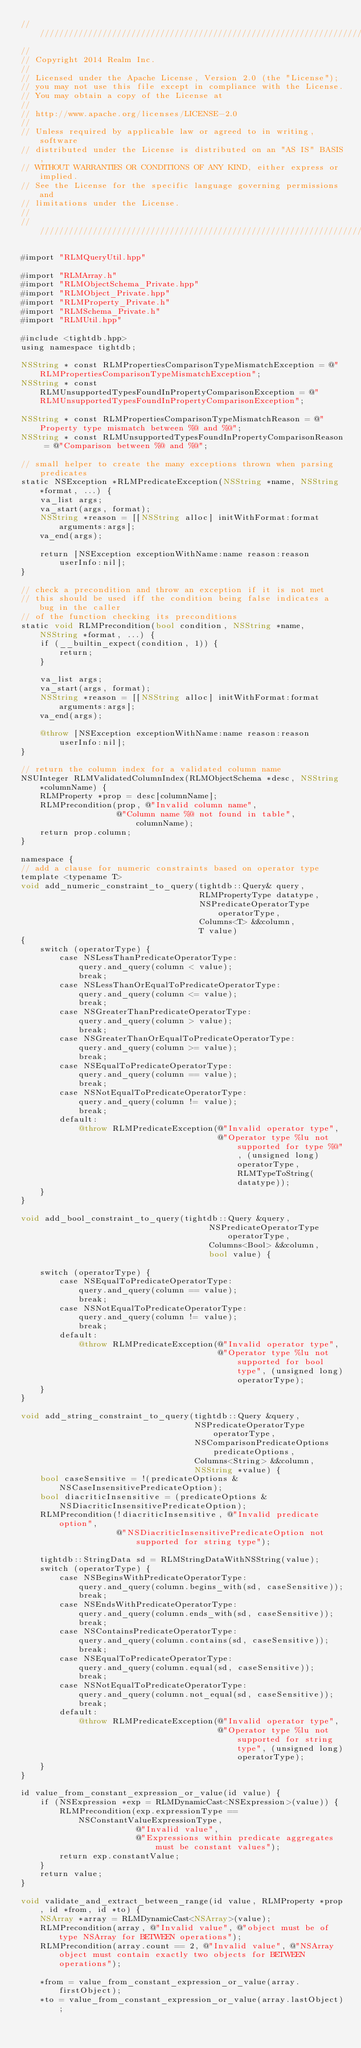Convert code to text. <code><loc_0><loc_0><loc_500><loc_500><_ObjectiveC_>////////////////////////////////////////////////////////////////////////////
//
// Copyright 2014 Realm Inc.
//
// Licensed under the Apache License, Version 2.0 (the "License");
// you may not use this file except in compliance with the License.
// You may obtain a copy of the License at
//
// http://www.apache.org/licenses/LICENSE-2.0
//
// Unless required by applicable law or agreed to in writing, software
// distributed under the License is distributed on an "AS IS" BASIS,
// WITHOUT WARRANTIES OR CONDITIONS OF ANY KIND, either express or implied.
// See the License for the specific language governing permissions and
// limitations under the License.
//
////////////////////////////////////////////////////////////////////////////

#import "RLMQueryUtil.hpp"

#import "RLMArray.h"
#import "RLMObjectSchema_Private.hpp"
#import "RLMObject_Private.hpp"
#import "RLMProperty_Private.h"
#import "RLMSchema_Private.h"
#import "RLMUtil.hpp"

#include <tightdb.hpp>
using namespace tightdb;

NSString * const RLMPropertiesComparisonTypeMismatchException = @"RLMPropertiesComparisonTypeMismatchException";
NSString * const RLMUnsupportedTypesFoundInPropertyComparisonException = @"RLMUnsupportedTypesFoundInPropertyComparisonException";

NSString * const RLMPropertiesComparisonTypeMismatchReason = @"Property type mismatch between %@ and %@";
NSString * const RLMUnsupportedTypesFoundInPropertyComparisonReason = @"Comparison between %@ and %@";

// small helper to create the many exceptions thrown when parsing predicates
static NSException *RLMPredicateException(NSString *name, NSString *format, ...) {
    va_list args;
    va_start(args, format);
    NSString *reason = [[NSString alloc] initWithFormat:format arguments:args];
    va_end(args);

    return [NSException exceptionWithName:name reason:reason userInfo:nil];
}

// check a precondition and throw an exception if it is not met
// this should be used iff the condition being false indicates a bug in the caller
// of the function checking its preconditions
static void RLMPrecondition(bool condition, NSString *name, NSString *format, ...) {
    if (__builtin_expect(condition, 1)) {
        return;
    }

    va_list args;
    va_start(args, format);
    NSString *reason = [[NSString alloc] initWithFormat:format arguments:args];
    va_end(args);

    @throw [NSException exceptionWithName:name reason:reason userInfo:nil];
}

// return the column index for a validated column name
NSUInteger RLMValidatedColumnIndex(RLMObjectSchema *desc, NSString *columnName) {
    RLMProperty *prop = desc[columnName];
    RLMPrecondition(prop, @"Invalid column name",
                    @"Column name %@ not found in table", columnName);
    return prop.column;
}

namespace {
// add a clause for numeric constraints based on operator type
template <typename T>
void add_numeric_constraint_to_query(tightdb::Query& query,
                                     RLMPropertyType datatype,
                                     NSPredicateOperatorType operatorType,
                                     Columns<T> &&column,
                                     T value)
{
    switch (operatorType) {
        case NSLessThanPredicateOperatorType:
            query.and_query(column < value);
            break;
        case NSLessThanOrEqualToPredicateOperatorType:
            query.and_query(column <= value);
            break;
        case NSGreaterThanPredicateOperatorType:
            query.and_query(column > value);
            break;
        case NSGreaterThanOrEqualToPredicateOperatorType:
            query.and_query(column >= value);
            break;
        case NSEqualToPredicateOperatorType:
            query.and_query(column == value);
            break;
        case NSNotEqualToPredicateOperatorType:
            query.and_query(column != value);
            break;
        default:
            @throw RLMPredicateException(@"Invalid operator type",
                                         @"Operator type %lu not supported for type %@", (unsigned long)operatorType, RLMTypeToString(datatype));
    }
}

void add_bool_constraint_to_query(tightdb::Query &query,
                                       NSPredicateOperatorType operatorType,
                                       Columns<Bool> &&column,
                                       bool value) {

    switch (operatorType) {
        case NSEqualToPredicateOperatorType:
            query.and_query(column == value);
            break;
        case NSNotEqualToPredicateOperatorType:
            query.and_query(column != value);
            break;
        default:
            @throw RLMPredicateException(@"Invalid operator type",
                                         @"Operator type %lu not supported for bool type", (unsigned long)operatorType);
    }
}

void add_string_constraint_to_query(tightdb::Query &query,
                                    NSPredicateOperatorType operatorType,
                                    NSComparisonPredicateOptions predicateOptions,
                                    Columns<String> &&column,
                                    NSString *value) {
    bool caseSensitive = !(predicateOptions & NSCaseInsensitivePredicateOption);
    bool diacriticInsensitive = (predicateOptions & NSDiacriticInsensitivePredicateOption);
    RLMPrecondition(!diacriticInsensitive, @"Invalid predicate option",
                    @"NSDiacriticInsensitivePredicateOption not supported for string type");

    tightdb::StringData sd = RLMStringDataWithNSString(value);
    switch (operatorType) {
        case NSBeginsWithPredicateOperatorType:
            query.and_query(column.begins_with(sd, caseSensitive));
            break;
        case NSEndsWithPredicateOperatorType:
            query.and_query(column.ends_with(sd, caseSensitive));
            break;
        case NSContainsPredicateOperatorType:
            query.and_query(column.contains(sd, caseSensitive));
            break;
        case NSEqualToPredicateOperatorType:
            query.and_query(column.equal(sd, caseSensitive));
            break;
        case NSNotEqualToPredicateOperatorType:
            query.and_query(column.not_equal(sd, caseSensitive));
            break;
        default:
            @throw RLMPredicateException(@"Invalid operator type",
                                         @"Operator type %lu not supported for string type", (unsigned long)operatorType);
    }
}

id value_from_constant_expression_or_value(id value) {
    if (NSExpression *exp = RLMDynamicCast<NSExpression>(value)) {
        RLMPrecondition(exp.expressionType == NSConstantValueExpressionType,
                        @"Invalid value",
                        @"Expressions within predicate aggregates must be constant values");
        return exp.constantValue;
    }
    return value;
}

void validate_and_extract_between_range(id value, RLMProperty *prop, id *from, id *to) {
    NSArray *array = RLMDynamicCast<NSArray>(value);
    RLMPrecondition(array, @"Invalid value", @"object must be of type NSArray for BETWEEN operations");
    RLMPrecondition(array.count == 2, @"Invalid value", @"NSArray object must contain exactly two objects for BETWEEN operations");

    *from = value_from_constant_expression_or_value(array.firstObject);
    *to = value_from_constant_expression_or_value(array.lastObject);</code> 